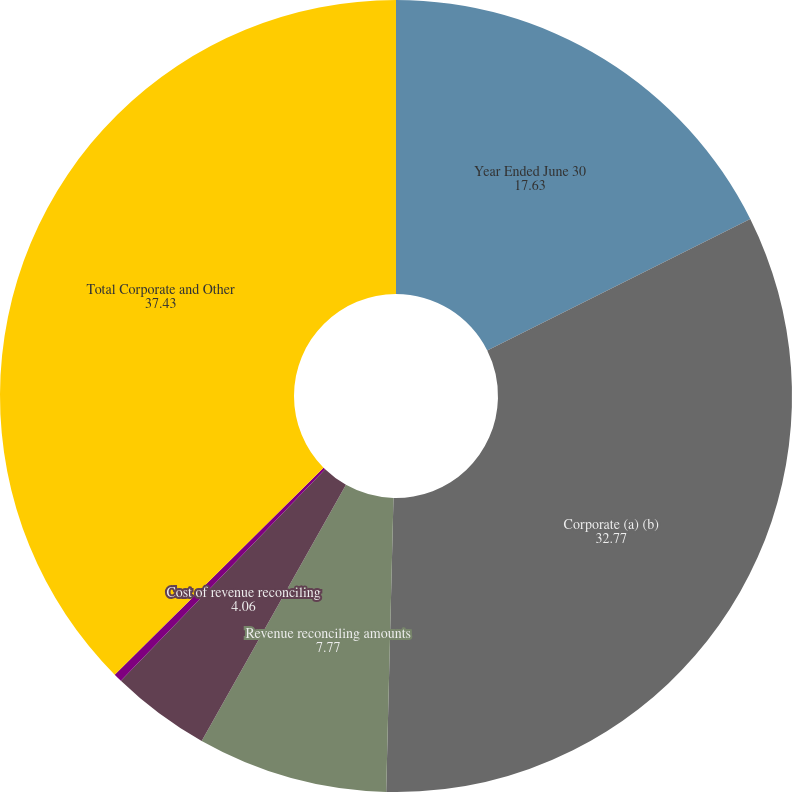Convert chart to OTSL. <chart><loc_0><loc_0><loc_500><loc_500><pie_chart><fcel>Year Ended June 30<fcel>Corporate (a) (b)<fcel>Revenue reconciling amounts<fcel>Cost of revenue reconciling<fcel>Operating expenses reconciling<fcel>Total Corporate and Other<nl><fcel>17.63%<fcel>32.77%<fcel>7.77%<fcel>4.06%<fcel>0.35%<fcel>37.43%<nl></chart> 